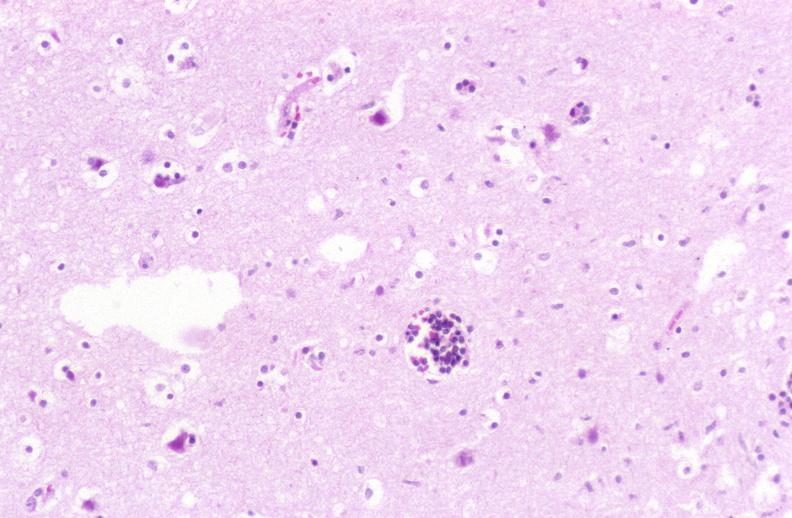s nervous present?
Answer the question using a single word or phrase. Yes 